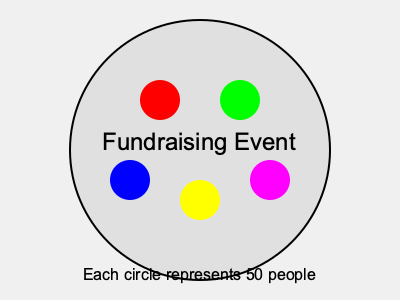In the fundraising event image, each colored circle represents 50 people. Estimate the total number of attendees at the event. To estimate the total number of attendees at the fundraising event, we need to follow these steps:

1. Count the number of colored circles in the image:
   There are 5 colored circles (red, green, blue, yellow, and magenta).

2. Recall that each circle represents 50 people:
   $50 \text{ people per circle}$

3. Calculate the total number of attendees by multiplying the number of circles by the number of people each circle represents:
   $5 \text{ circles} \times 50 \text{ people per circle} = 250 \text{ people}$

Therefore, the estimated total number of attendees at the fundraising event is 250 people.
Answer: 250 people 